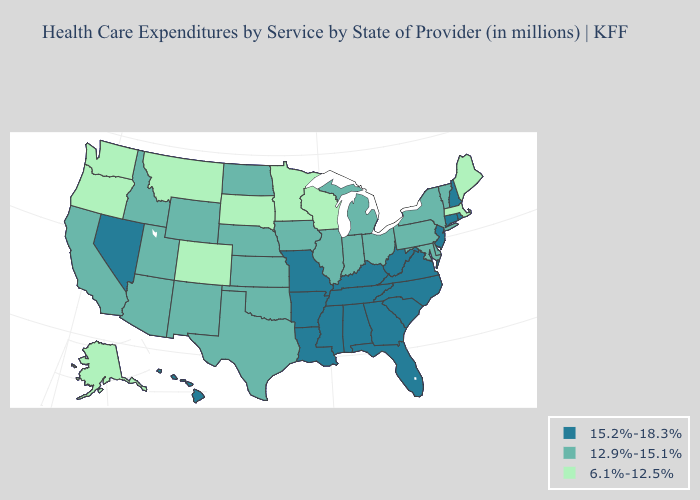Which states have the highest value in the USA?
Answer briefly. Alabama, Arkansas, Connecticut, Florida, Georgia, Hawaii, Kentucky, Louisiana, Mississippi, Missouri, Nevada, New Hampshire, New Jersey, North Carolina, Rhode Island, South Carolina, Tennessee, Virginia, West Virginia. Which states hav the highest value in the South?
Give a very brief answer. Alabama, Arkansas, Florida, Georgia, Kentucky, Louisiana, Mississippi, North Carolina, South Carolina, Tennessee, Virginia, West Virginia. Does Montana have the highest value in the USA?
Write a very short answer. No. Name the states that have a value in the range 12.9%-15.1%?
Give a very brief answer. Arizona, California, Delaware, Idaho, Illinois, Indiana, Iowa, Kansas, Maryland, Michigan, Nebraska, New Mexico, New York, North Dakota, Ohio, Oklahoma, Pennsylvania, Texas, Utah, Vermont, Wyoming. What is the value of Florida?
Short answer required. 15.2%-18.3%. Name the states that have a value in the range 6.1%-12.5%?
Short answer required. Alaska, Colorado, Maine, Massachusetts, Minnesota, Montana, Oregon, South Dakota, Washington, Wisconsin. Does Michigan have a higher value than Alaska?
Short answer required. Yes. Among the states that border Indiana , does Michigan have the highest value?
Short answer required. No. What is the value of Florida?
Answer briefly. 15.2%-18.3%. What is the value of West Virginia?
Be succinct. 15.2%-18.3%. Does New Mexico have the lowest value in the USA?
Keep it brief. No. Does Arkansas have the lowest value in the South?
Answer briefly. No. Which states have the highest value in the USA?
Answer briefly. Alabama, Arkansas, Connecticut, Florida, Georgia, Hawaii, Kentucky, Louisiana, Mississippi, Missouri, Nevada, New Hampshire, New Jersey, North Carolina, Rhode Island, South Carolina, Tennessee, Virginia, West Virginia. Does Kentucky have the lowest value in the USA?
Concise answer only. No. What is the lowest value in states that border Maryland?
Quick response, please. 12.9%-15.1%. 